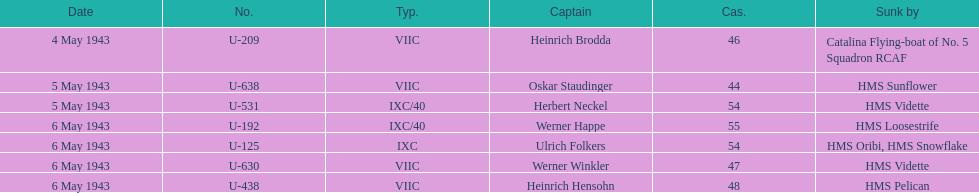What is the only vessel to sink multiple u-boats? HMS Vidette. 